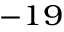Convert formula to latex. <formula><loc_0><loc_0><loc_500><loc_500>^ { - 1 9 }</formula> 